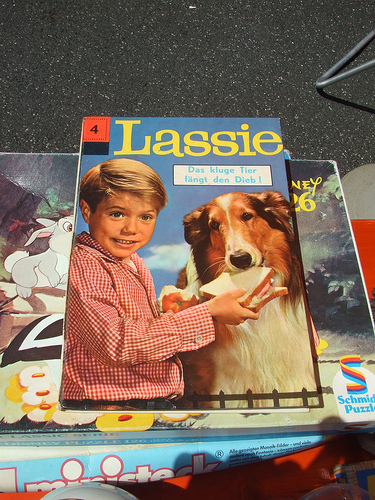<image>
Is the boy behind the dog? No. The boy is not behind the dog. From this viewpoint, the boy appears to be positioned elsewhere in the scene. Where is the dog in relation to the boy? Is it on the boy? No. The dog is not positioned on the boy. They may be near each other, but the dog is not supported by or resting on top of the boy. 